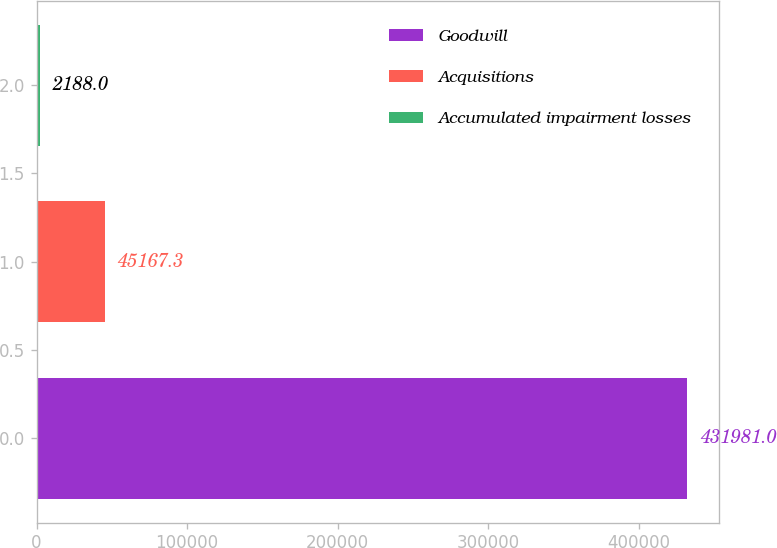<chart> <loc_0><loc_0><loc_500><loc_500><bar_chart><fcel>Goodwill<fcel>Acquisitions<fcel>Accumulated impairment losses<nl><fcel>431981<fcel>45167.3<fcel>2188<nl></chart> 